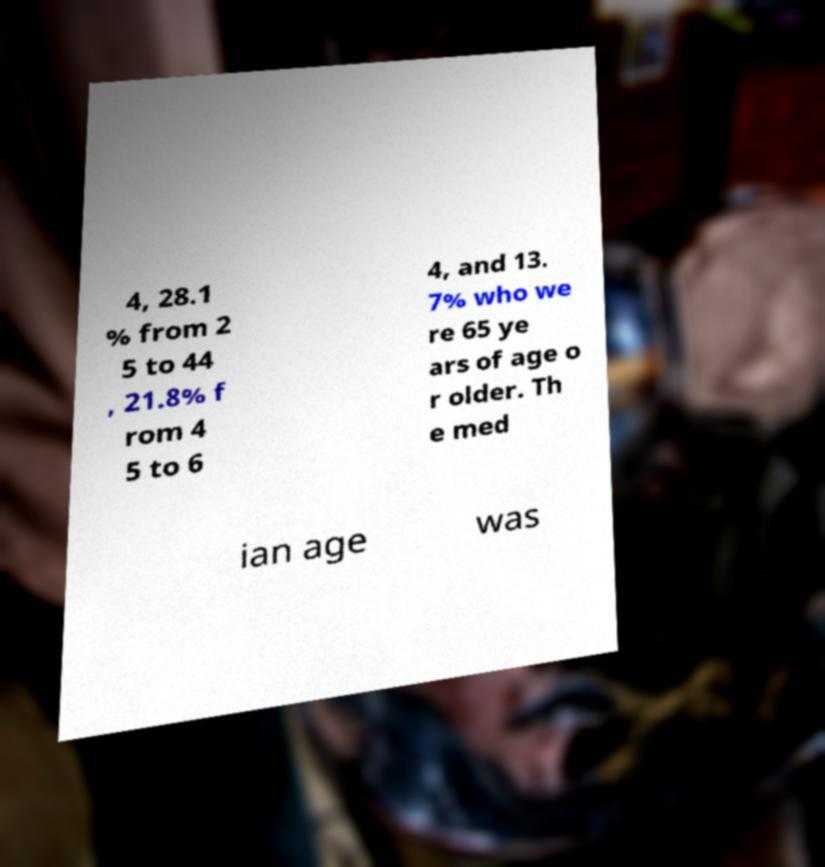Can you accurately transcribe the text from the provided image for me? 4, 28.1 % from 2 5 to 44 , 21.8% f rom 4 5 to 6 4, and 13. 7% who we re 65 ye ars of age o r older. Th e med ian age was 